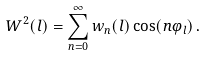<formula> <loc_0><loc_0><loc_500><loc_500>W ^ { 2 } ( l ) = \sum _ { n = 0 } ^ { \infty } w _ { n } ( l ) \cos ( n \varphi _ { l } ) \, .</formula> 